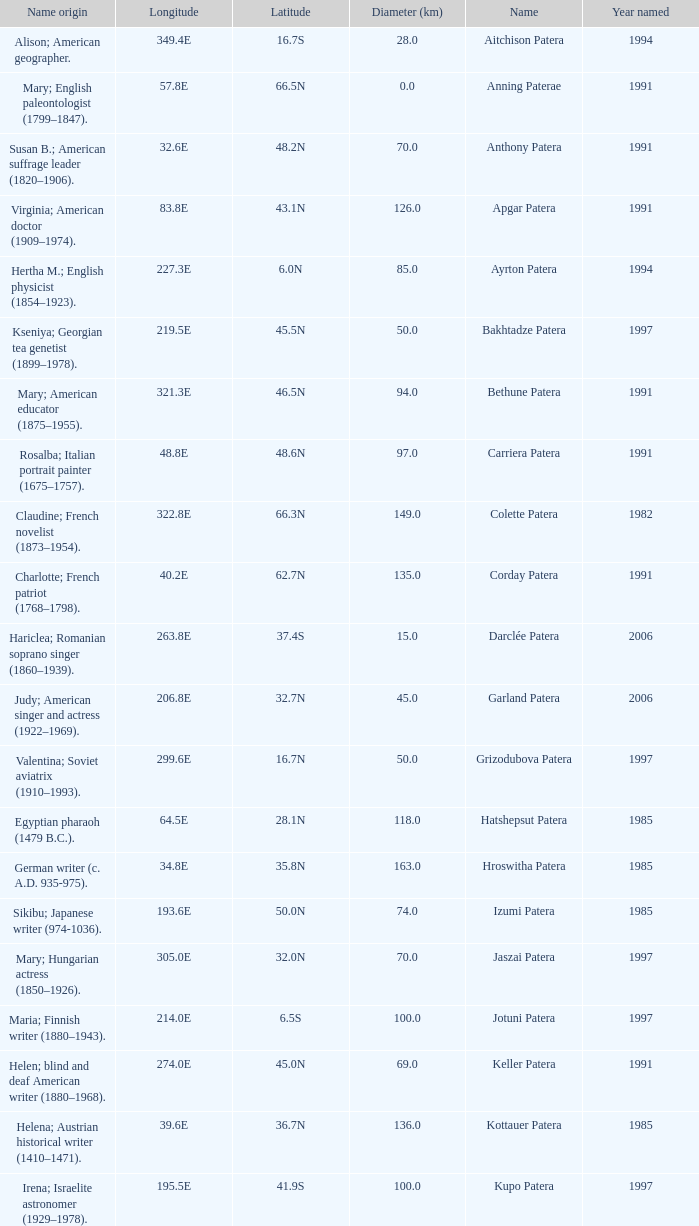What is the diameter in km of the feature named Colette Patera?  149.0. 